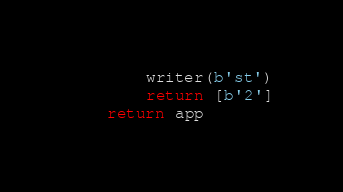Convert code to text. <code><loc_0><loc_0><loc_500><loc_500><_Python_>        writer(b'st')
        return [b'2']
    return app
</code> 